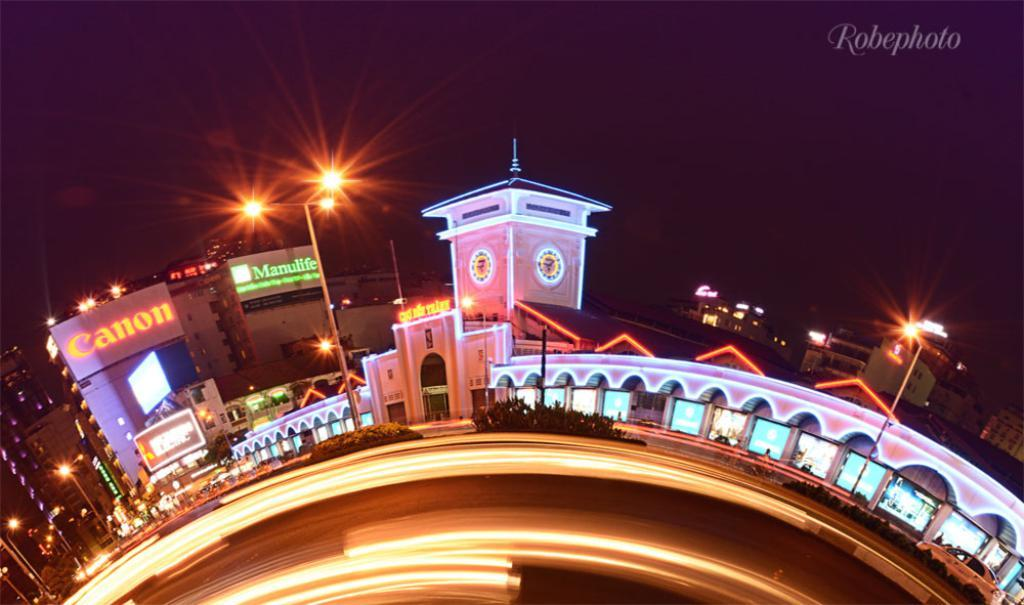<image>
Give a short and clear explanation of the subsequent image. A view of the city with Canon and Manulife buildings at the background. 